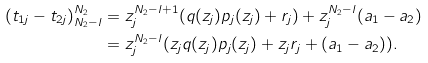Convert formula to latex. <formula><loc_0><loc_0><loc_500><loc_500>( t _ { 1 j } - t _ { 2 j } ) _ { N _ { 2 } - l } ^ { N _ { 2 } } & = z _ { j } ^ { N _ { 2 } - l + 1 } ( q ( z _ { j } ) p _ { j } ( z _ { j } ) + r _ { j } ) + z _ { j } ^ { N _ { 2 } - l } ( a _ { 1 } - a _ { 2 } ) \\ & = z _ { j } ^ { N _ { 2 } - l } ( z _ { j } q ( z _ { j } ) p _ { j } ( z _ { j } ) + z _ { j } r _ { j } + ( a _ { 1 } - a _ { 2 } ) ) .</formula> 